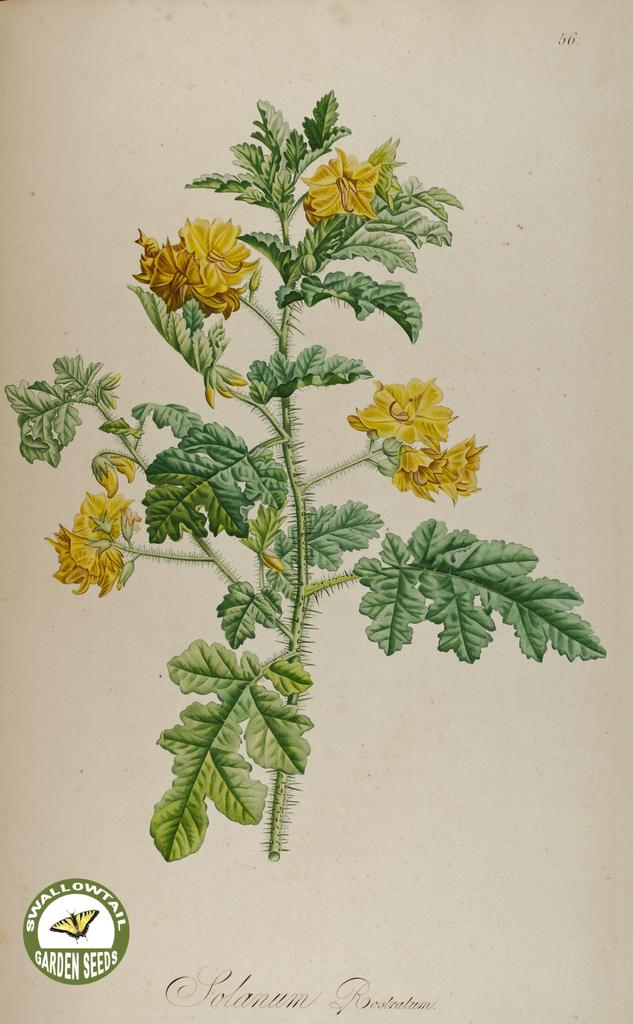What type of artwork is shown in the image? The image is a painting. What is the main subject of the painting? The painting depicts a plant. What color are the flowers on the plant? There are yellow flowers on the plant. What additional information is present at the bottom of the painting? There is text and a logo at the bottom of the painting. Can you see a ship sailing in the sky in the painting? No, there is no ship sailing in the sky in the painting. The painting depicts a plant with yellow flowers, and there is no reference to a ship or the sky. 